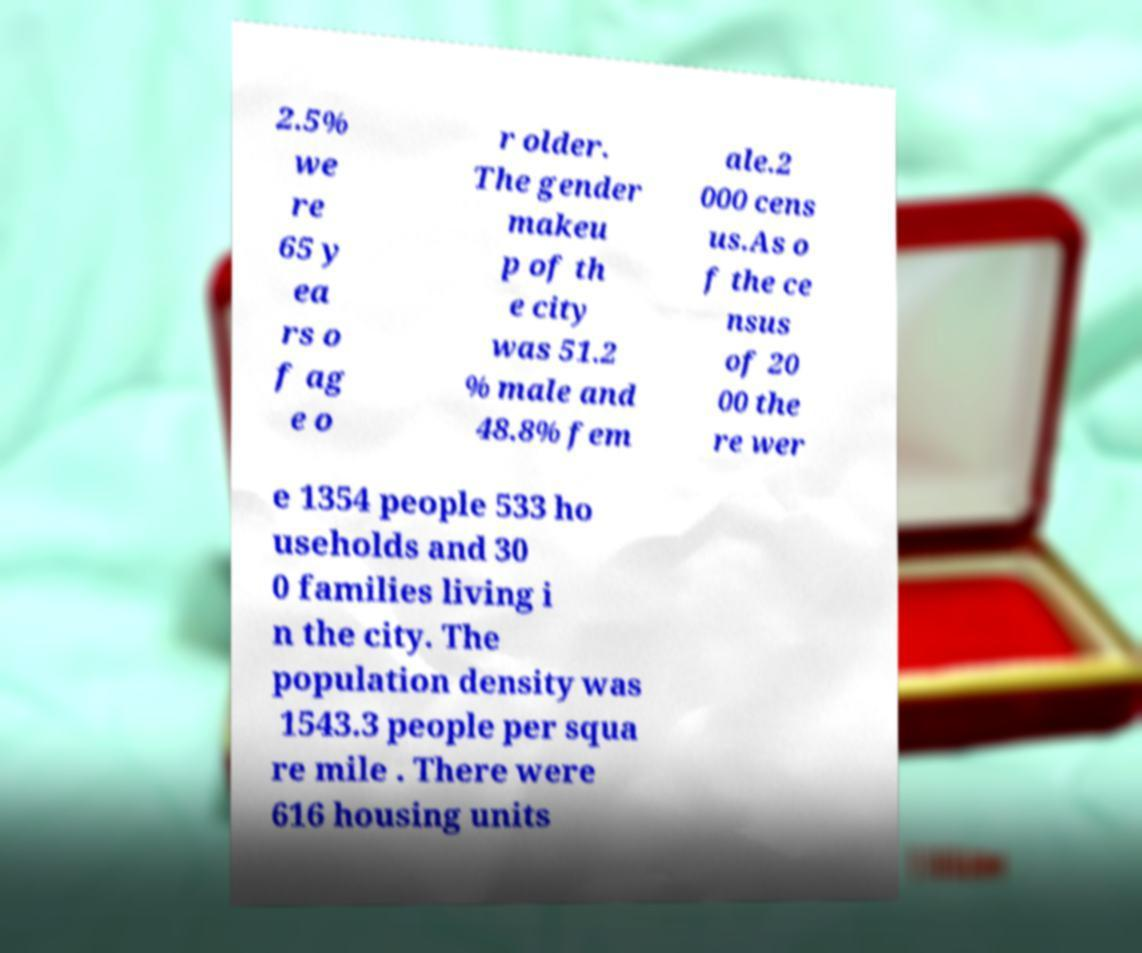What messages or text are displayed in this image? I need them in a readable, typed format. 2.5% we re 65 y ea rs o f ag e o r older. The gender makeu p of th e city was 51.2 % male and 48.8% fem ale.2 000 cens us.As o f the ce nsus of 20 00 the re wer e 1354 people 533 ho useholds and 30 0 families living i n the city. The population density was 1543.3 people per squa re mile . There were 616 housing units 